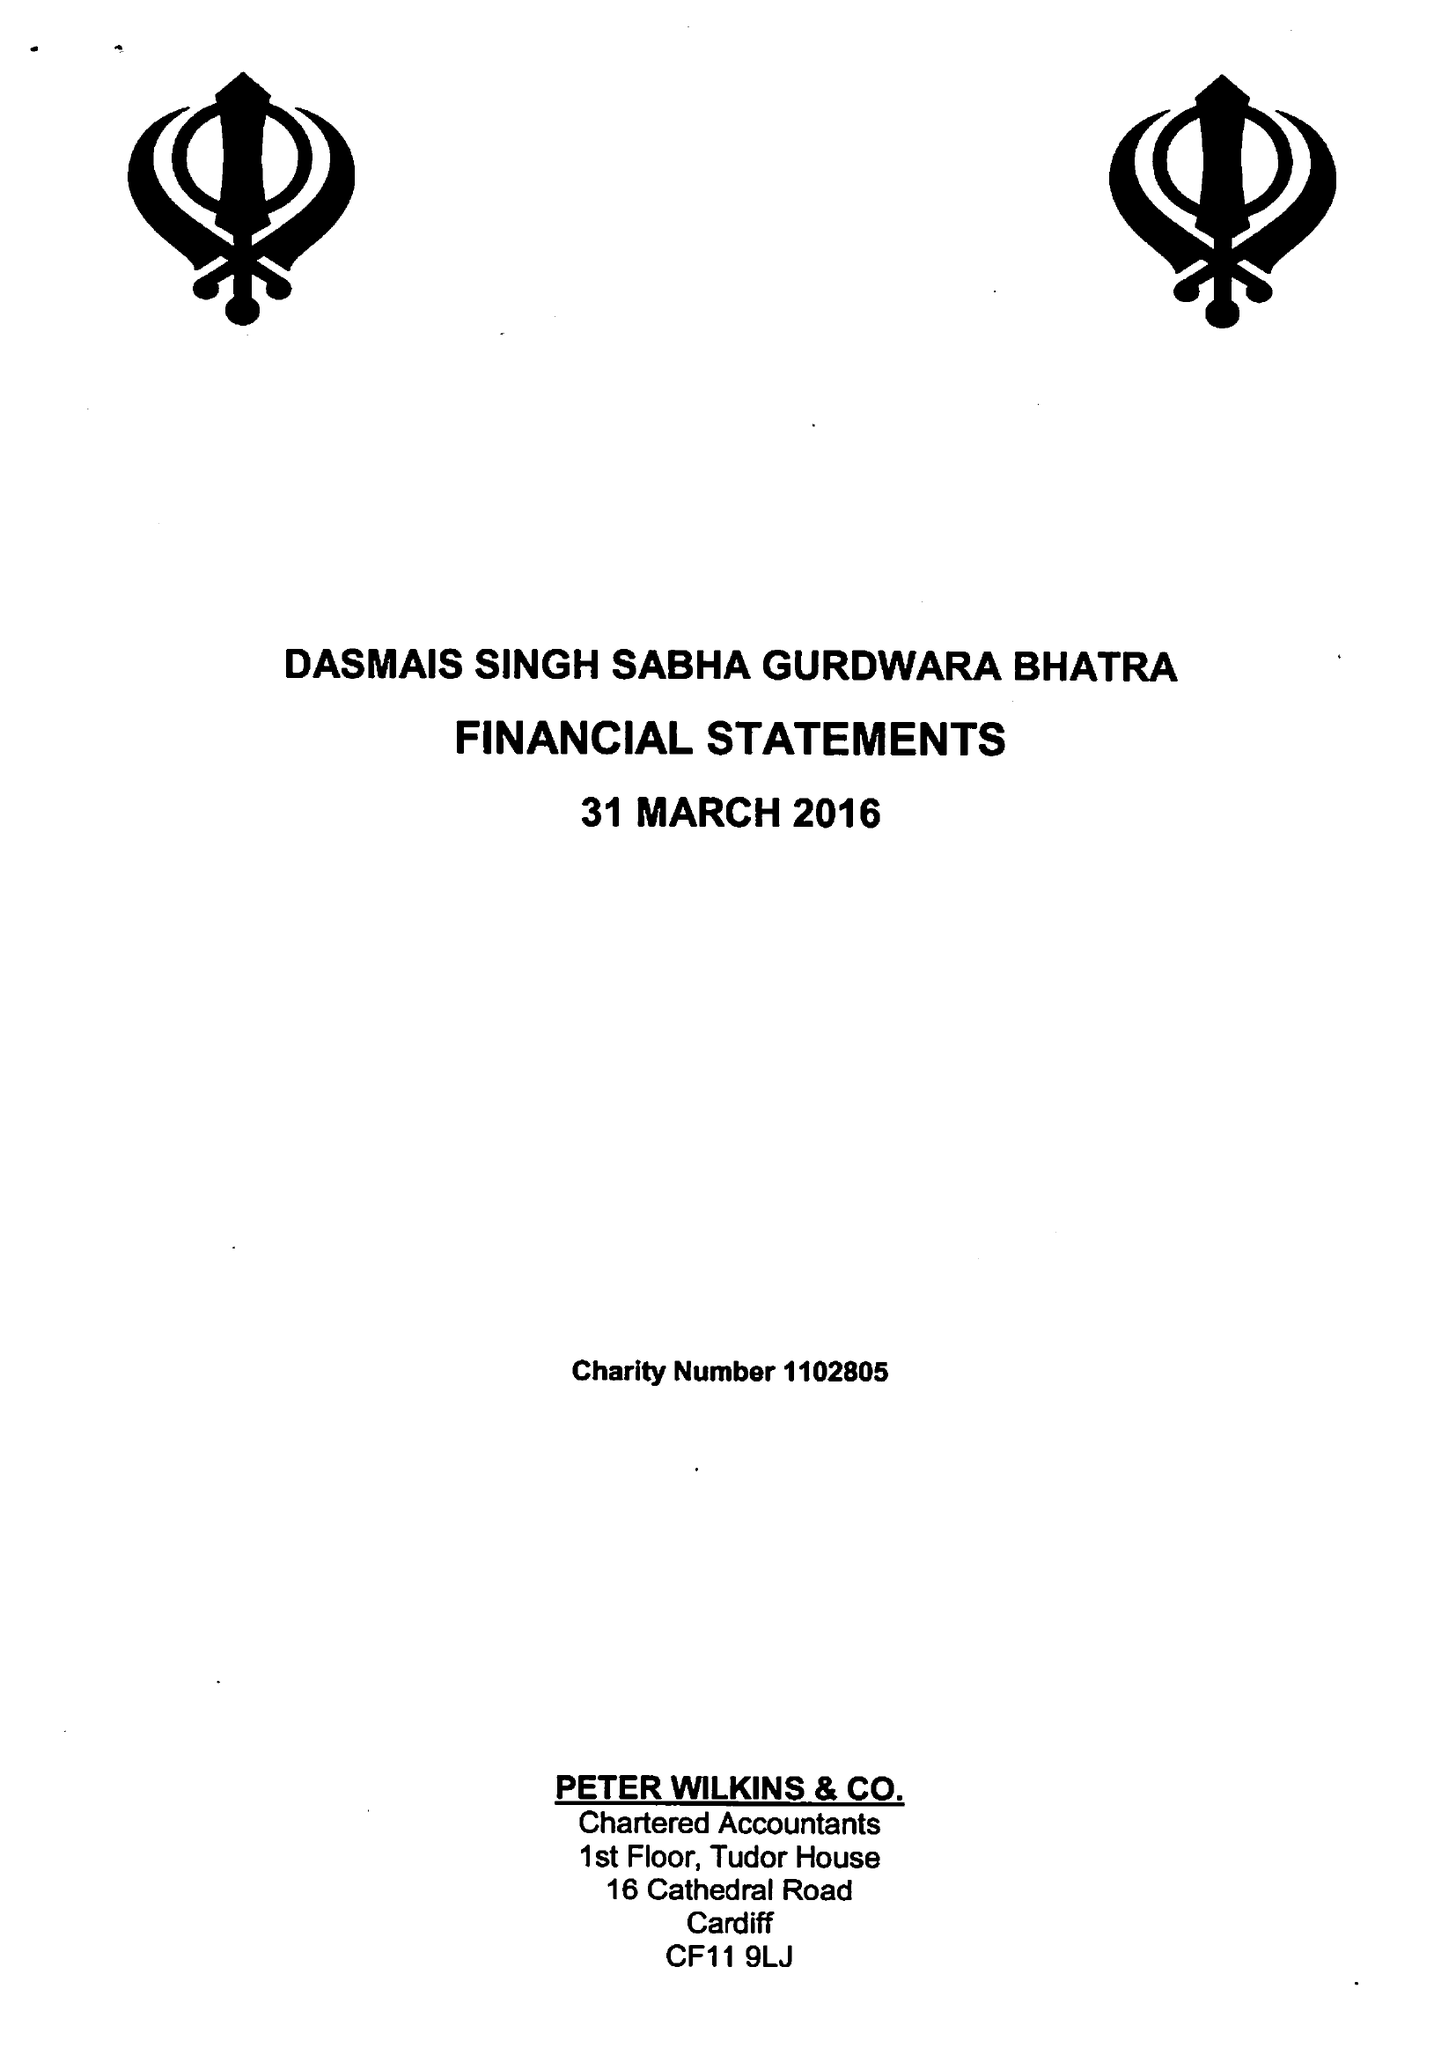What is the value for the spending_annually_in_british_pounds?
Answer the question using a single word or phrase. 31790.00 